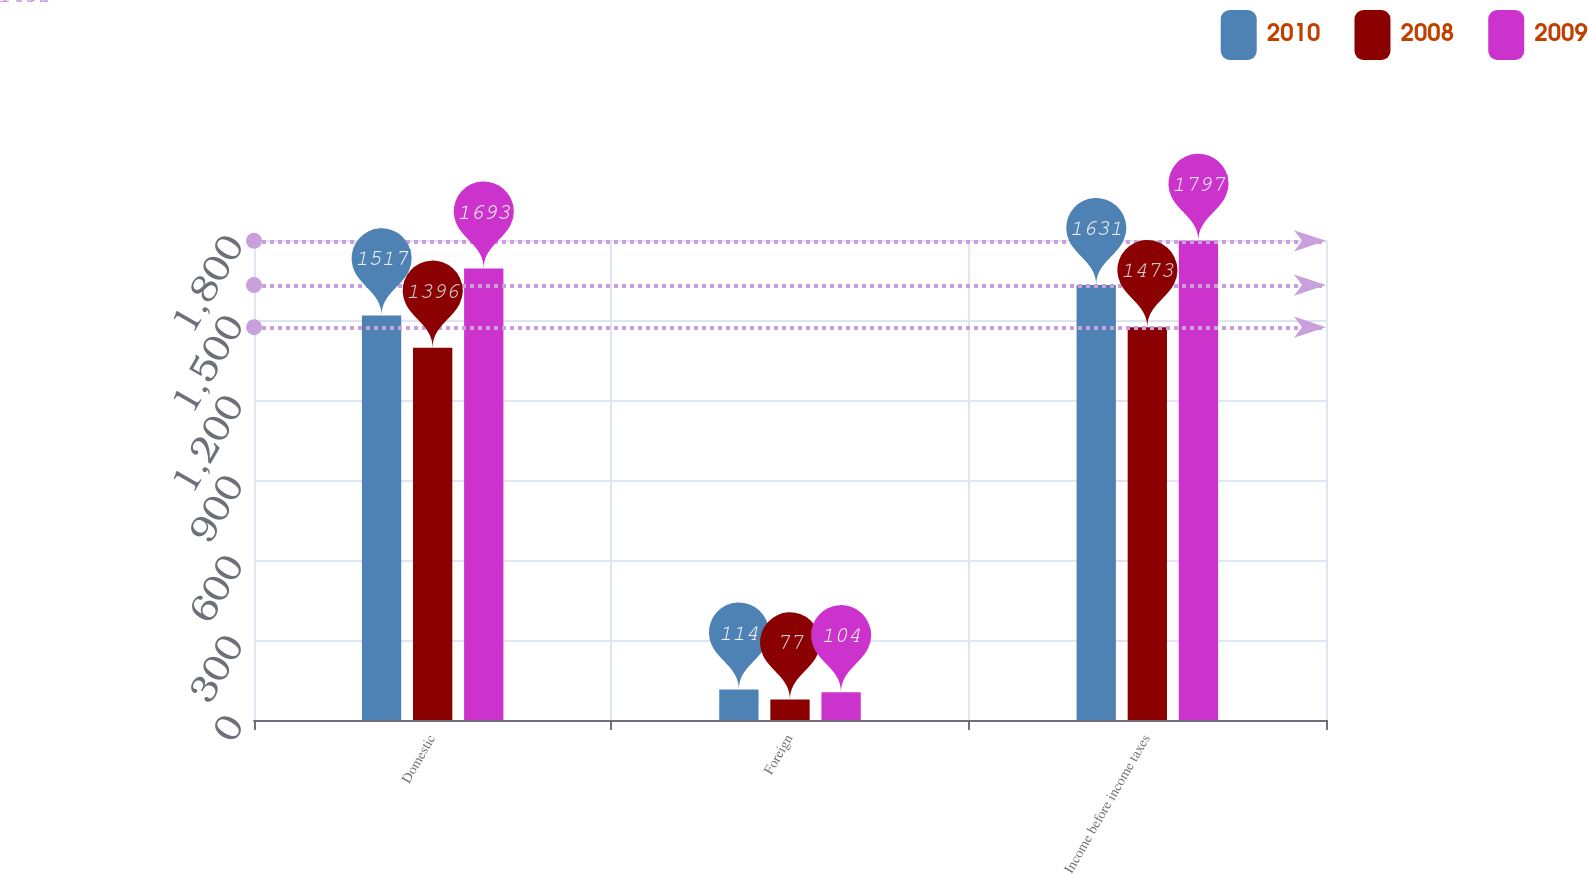Convert chart to OTSL. <chart><loc_0><loc_0><loc_500><loc_500><stacked_bar_chart><ecel><fcel>Domestic<fcel>Foreign<fcel>Income before income taxes<nl><fcel>2010<fcel>1517<fcel>114<fcel>1631<nl><fcel>2008<fcel>1396<fcel>77<fcel>1473<nl><fcel>2009<fcel>1693<fcel>104<fcel>1797<nl></chart> 